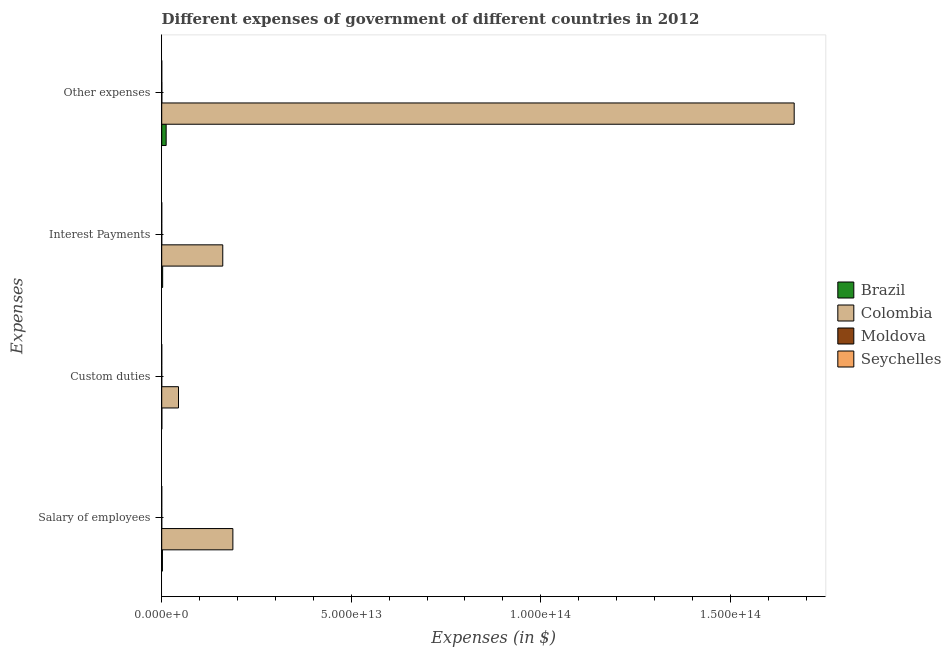How many different coloured bars are there?
Offer a very short reply. 4. Are the number of bars per tick equal to the number of legend labels?
Provide a succinct answer. Yes. How many bars are there on the 3rd tick from the top?
Offer a very short reply. 4. What is the label of the 3rd group of bars from the top?
Your answer should be compact. Custom duties. What is the amount spent on salary of employees in Colombia?
Offer a very short reply. 1.88e+13. Across all countries, what is the maximum amount spent on salary of employees?
Provide a succinct answer. 1.88e+13. Across all countries, what is the minimum amount spent on custom duties?
Offer a terse response. 1.13e+09. In which country was the amount spent on custom duties minimum?
Keep it short and to the point. Seychelles. What is the total amount spent on interest payments in the graph?
Keep it short and to the point. 1.64e+13. What is the difference between the amount spent on interest payments in Colombia and that in Brazil?
Provide a succinct answer. 1.59e+13. What is the difference between the amount spent on custom duties in Moldova and the amount spent on interest payments in Colombia?
Your answer should be very brief. -1.61e+13. What is the average amount spent on other expenses per country?
Your response must be concise. 4.20e+13. What is the difference between the amount spent on other expenses and amount spent on interest payments in Colombia?
Provide a succinct answer. 1.51e+14. What is the ratio of the amount spent on salary of employees in Moldova to that in Colombia?
Make the answer very short. 0. Is the amount spent on other expenses in Brazil less than that in Seychelles?
Your answer should be compact. No. Is the difference between the amount spent on interest payments in Seychelles and Brazil greater than the difference between the amount spent on custom duties in Seychelles and Brazil?
Your response must be concise. No. What is the difference between the highest and the second highest amount spent on interest payments?
Your answer should be compact. 1.59e+13. What is the difference between the highest and the lowest amount spent on custom duties?
Your response must be concise. 4.43e+12. Is the sum of the amount spent on salary of employees in Seychelles and Moldova greater than the maximum amount spent on other expenses across all countries?
Your response must be concise. No. Is it the case that in every country, the sum of the amount spent on interest payments and amount spent on other expenses is greater than the sum of amount spent on custom duties and amount spent on salary of employees?
Provide a succinct answer. No. What does the 2nd bar from the top in Other expenses represents?
Your response must be concise. Moldova. What does the 2nd bar from the bottom in Salary of employees represents?
Provide a short and direct response. Colombia. How many bars are there?
Provide a succinct answer. 16. How many countries are there in the graph?
Provide a succinct answer. 4. What is the difference between two consecutive major ticks on the X-axis?
Ensure brevity in your answer.  5.00e+13. Are the values on the major ticks of X-axis written in scientific E-notation?
Provide a short and direct response. Yes. Does the graph contain any zero values?
Provide a succinct answer. No. How are the legend labels stacked?
Your answer should be compact. Vertical. What is the title of the graph?
Make the answer very short. Different expenses of government of different countries in 2012. Does "Morocco" appear as one of the legend labels in the graph?
Ensure brevity in your answer.  No. What is the label or title of the X-axis?
Keep it short and to the point. Expenses (in $). What is the label or title of the Y-axis?
Provide a succinct answer. Expenses. What is the Expenses (in $) of Brazil in Salary of employees?
Your answer should be compact. 1.86e+11. What is the Expenses (in $) of Colombia in Salary of employees?
Ensure brevity in your answer.  1.88e+13. What is the Expenses (in $) of Moldova in Salary of employees?
Offer a very short reply. 3.94e+09. What is the Expenses (in $) of Seychelles in Salary of employees?
Offer a very short reply. 1.18e+09. What is the Expenses (in $) in Brazil in Custom duties?
Provide a succinct answer. 3.11e+1. What is the Expenses (in $) in Colombia in Custom duties?
Your answer should be compact. 4.43e+12. What is the Expenses (in $) of Moldova in Custom duties?
Provide a succinct answer. 1.25e+09. What is the Expenses (in $) of Seychelles in Custom duties?
Your answer should be compact. 1.13e+09. What is the Expenses (in $) in Brazil in Interest Payments?
Keep it short and to the point. 2.48e+11. What is the Expenses (in $) of Colombia in Interest Payments?
Provide a succinct answer. 1.61e+13. What is the Expenses (in $) in Moldova in Interest Payments?
Keep it short and to the point. 6.66e+08. What is the Expenses (in $) in Seychelles in Interest Payments?
Offer a very short reply. 5.62e+08. What is the Expenses (in $) in Brazil in Other expenses?
Your answer should be compact. 1.17e+12. What is the Expenses (in $) in Colombia in Other expenses?
Provide a short and direct response. 1.67e+14. What is the Expenses (in $) in Moldova in Other expenses?
Offer a terse response. 2.94e+1. What is the Expenses (in $) in Seychelles in Other expenses?
Offer a terse response. 4.04e+09. Across all Expenses, what is the maximum Expenses (in $) in Brazil?
Make the answer very short. 1.17e+12. Across all Expenses, what is the maximum Expenses (in $) in Colombia?
Offer a very short reply. 1.67e+14. Across all Expenses, what is the maximum Expenses (in $) of Moldova?
Offer a terse response. 2.94e+1. Across all Expenses, what is the maximum Expenses (in $) of Seychelles?
Offer a terse response. 4.04e+09. Across all Expenses, what is the minimum Expenses (in $) in Brazil?
Provide a succinct answer. 3.11e+1. Across all Expenses, what is the minimum Expenses (in $) in Colombia?
Your response must be concise. 4.43e+12. Across all Expenses, what is the minimum Expenses (in $) in Moldova?
Provide a succinct answer. 6.66e+08. Across all Expenses, what is the minimum Expenses (in $) of Seychelles?
Your answer should be very brief. 5.62e+08. What is the total Expenses (in $) in Brazil in the graph?
Keep it short and to the point. 1.64e+12. What is the total Expenses (in $) in Colombia in the graph?
Your answer should be very brief. 2.06e+14. What is the total Expenses (in $) in Moldova in the graph?
Offer a terse response. 3.52e+1. What is the total Expenses (in $) in Seychelles in the graph?
Keep it short and to the point. 6.91e+09. What is the difference between the Expenses (in $) of Brazil in Salary of employees and that in Custom duties?
Provide a succinct answer. 1.55e+11. What is the difference between the Expenses (in $) in Colombia in Salary of employees and that in Custom duties?
Provide a short and direct response. 1.43e+13. What is the difference between the Expenses (in $) of Moldova in Salary of employees and that in Custom duties?
Make the answer very short. 2.70e+09. What is the difference between the Expenses (in $) of Seychelles in Salary of employees and that in Custom duties?
Ensure brevity in your answer.  4.31e+07. What is the difference between the Expenses (in $) in Brazil in Salary of employees and that in Interest Payments?
Make the answer very short. -6.16e+1. What is the difference between the Expenses (in $) of Colombia in Salary of employees and that in Interest Payments?
Provide a short and direct response. 2.67e+12. What is the difference between the Expenses (in $) of Moldova in Salary of employees and that in Interest Payments?
Offer a very short reply. 3.28e+09. What is the difference between the Expenses (in $) in Seychelles in Salary of employees and that in Interest Payments?
Ensure brevity in your answer.  6.14e+08. What is the difference between the Expenses (in $) in Brazil in Salary of employees and that in Other expenses?
Provide a succinct answer. -9.85e+11. What is the difference between the Expenses (in $) of Colombia in Salary of employees and that in Other expenses?
Offer a very short reply. -1.48e+14. What is the difference between the Expenses (in $) in Moldova in Salary of employees and that in Other expenses?
Offer a very short reply. -2.54e+1. What is the difference between the Expenses (in $) of Seychelles in Salary of employees and that in Other expenses?
Ensure brevity in your answer.  -2.86e+09. What is the difference between the Expenses (in $) in Brazil in Custom duties and that in Interest Payments?
Give a very brief answer. -2.17e+11. What is the difference between the Expenses (in $) in Colombia in Custom duties and that in Interest Payments?
Provide a succinct answer. -1.17e+13. What is the difference between the Expenses (in $) of Moldova in Custom duties and that in Interest Payments?
Offer a terse response. 5.81e+08. What is the difference between the Expenses (in $) of Seychelles in Custom duties and that in Interest Payments?
Keep it short and to the point. 5.71e+08. What is the difference between the Expenses (in $) in Brazil in Custom duties and that in Other expenses?
Your response must be concise. -1.14e+12. What is the difference between the Expenses (in $) of Colombia in Custom duties and that in Other expenses?
Offer a terse response. -1.62e+14. What is the difference between the Expenses (in $) in Moldova in Custom duties and that in Other expenses?
Your response must be concise. -2.81e+1. What is the difference between the Expenses (in $) of Seychelles in Custom duties and that in Other expenses?
Make the answer very short. -2.90e+09. What is the difference between the Expenses (in $) of Brazil in Interest Payments and that in Other expenses?
Your answer should be very brief. -9.23e+11. What is the difference between the Expenses (in $) of Colombia in Interest Payments and that in Other expenses?
Offer a terse response. -1.51e+14. What is the difference between the Expenses (in $) in Moldova in Interest Payments and that in Other expenses?
Provide a short and direct response. -2.87e+1. What is the difference between the Expenses (in $) of Seychelles in Interest Payments and that in Other expenses?
Your response must be concise. -3.47e+09. What is the difference between the Expenses (in $) in Brazil in Salary of employees and the Expenses (in $) in Colombia in Custom duties?
Offer a terse response. -4.24e+12. What is the difference between the Expenses (in $) of Brazil in Salary of employees and the Expenses (in $) of Moldova in Custom duties?
Your answer should be compact. 1.85e+11. What is the difference between the Expenses (in $) of Brazil in Salary of employees and the Expenses (in $) of Seychelles in Custom duties?
Your answer should be very brief. 1.85e+11. What is the difference between the Expenses (in $) of Colombia in Salary of employees and the Expenses (in $) of Moldova in Custom duties?
Provide a short and direct response. 1.88e+13. What is the difference between the Expenses (in $) in Colombia in Salary of employees and the Expenses (in $) in Seychelles in Custom duties?
Offer a terse response. 1.88e+13. What is the difference between the Expenses (in $) of Moldova in Salary of employees and the Expenses (in $) of Seychelles in Custom duties?
Your answer should be very brief. 2.81e+09. What is the difference between the Expenses (in $) of Brazil in Salary of employees and the Expenses (in $) of Colombia in Interest Payments?
Make the answer very short. -1.59e+13. What is the difference between the Expenses (in $) of Brazil in Salary of employees and the Expenses (in $) of Moldova in Interest Payments?
Your answer should be compact. 1.85e+11. What is the difference between the Expenses (in $) of Brazil in Salary of employees and the Expenses (in $) of Seychelles in Interest Payments?
Offer a very short reply. 1.86e+11. What is the difference between the Expenses (in $) of Colombia in Salary of employees and the Expenses (in $) of Moldova in Interest Payments?
Ensure brevity in your answer.  1.88e+13. What is the difference between the Expenses (in $) in Colombia in Salary of employees and the Expenses (in $) in Seychelles in Interest Payments?
Keep it short and to the point. 1.88e+13. What is the difference between the Expenses (in $) of Moldova in Salary of employees and the Expenses (in $) of Seychelles in Interest Payments?
Make the answer very short. 3.38e+09. What is the difference between the Expenses (in $) in Brazil in Salary of employees and the Expenses (in $) in Colombia in Other expenses?
Your answer should be very brief. -1.67e+14. What is the difference between the Expenses (in $) in Brazil in Salary of employees and the Expenses (in $) in Moldova in Other expenses?
Your response must be concise. 1.57e+11. What is the difference between the Expenses (in $) of Brazil in Salary of employees and the Expenses (in $) of Seychelles in Other expenses?
Your answer should be very brief. 1.82e+11. What is the difference between the Expenses (in $) of Colombia in Salary of employees and the Expenses (in $) of Moldova in Other expenses?
Ensure brevity in your answer.  1.87e+13. What is the difference between the Expenses (in $) of Colombia in Salary of employees and the Expenses (in $) of Seychelles in Other expenses?
Your response must be concise. 1.88e+13. What is the difference between the Expenses (in $) of Moldova in Salary of employees and the Expenses (in $) of Seychelles in Other expenses?
Give a very brief answer. -9.21e+07. What is the difference between the Expenses (in $) of Brazil in Custom duties and the Expenses (in $) of Colombia in Interest Payments?
Make the answer very short. -1.61e+13. What is the difference between the Expenses (in $) in Brazil in Custom duties and the Expenses (in $) in Moldova in Interest Payments?
Give a very brief answer. 3.04e+1. What is the difference between the Expenses (in $) of Brazil in Custom duties and the Expenses (in $) of Seychelles in Interest Payments?
Provide a succinct answer. 3.05e+1. What is the difference between the Expenses (in $) of Colombia in Custom duties and the Expenses (in $) of Moldova in Interest Payments?
Give a very brief answer. 4.43e+12. What is the difference between the Expenses (in $) in Colombia in Custom duties and the Expenses (in $) in Seychelles in Interest Payments?
Your answer should be compact. 4.43e+12. What is the difference between the Expenses (in $) of Moldova in Custom duties and the Expenses (in $) of Seychelles in Interest Payments?
Provide a short and direct response. 6.86e+08. What is the difference between the Expenses (in $) in Brazil in Custom duties and the Expenses (in $) in Colombia in Other expenses?
Provide a succinct answer. -1.67e+14. What is the difference between the Expenses (in $) in Brazil in Custom duties and the Expenses (in $) in Moldova in Other expenses?
Your answer should be very brief. 1.69e+09. What is the difference between the Expenses (in $) in Brazil in Custom duties and the Expenses (in $) in Seychelles in Other expenses?
Your response must be concise. 2.70e+1. What is the difference between the Expenses (in $) in Colombia in Custom duties and the Expenses (in $) in Moldova in Other expenses?
Make the answer very short. 4.40e+12. What is the difference between the Expenses (in $) of Colombia in Custom duties and the Expenses (in $) of Seychelles in Other expenses?
Make the answer very short. 4.42e+12. What is the difference between the Expenses (in $) of Moldova in Custom duties and the Expenses (in $) of Seychelles in Other expenses?
Provide a succinct answer. -2.79e+09. What is the difference between the Expenses (in $) of Brazil in Interest Payments and the Expenses (in $) of Colombia in Other expenses?
Provide a short and direct response. -1.67e+14. What is the difference between the Expenses (in $) in Brazil in Interest Payments and the Expenses (in $) in Moldova in Other expenses?
Offer a terse response. 2.18e+11. What is the difference between the Expenses (in $) in Brazil in Interest Payments and the Expenses (in $) in Seychelles in Other expenses?
Ensure brevity in your answer.  2.44e+11. What is the difference between the Expenses (in $) in Colombia in Interest Payments and the Expenses (in $) in Moldova in Other expenses?
Give a very brief answer. 1.61e+13. What is the difference between the Expenses (in $) of Colombia in Interest Payments and the Expenses (in $) of Seychelles in Other expenses?
Give a very brief answer. 1.61e+13. What is the difference between the Expenses (in $) of Moldova in Interest Payments and the Expenses (in $) of Seychelles in Other expenses?
Offer a terse response. -3.37e+09. What is the average Expenses (in $) of Brazil per Expenses?
Give a very brief answer. 4.09e+11. What is the average Expenses (in $) in Colombia per Expenses?
Offer a very short reply. 5.15e+13. What is the average Expenses (in $) of Moldova per Expenses?
Provide a succinct answer. 8.81e+09. What is the average Expenses (in $) in Seychelles per Expenses?
Your answer should be very brief. 1.73e+09. What is the difference between the Expenses (in $) in Brazil and Expenses (in $) in Colombia in Salary of employees?
Offer a very short reply. -1.86e+13. What is the difference between the Expenses (in $) in Brazil and Expenses (in $) in Moldova in Salary of employees?
Give a very brief answer. 1.82e+11. What is the difference between the Expenses (in $) in Brazil and Expenses (in $) in Seychelles in Salary of employees?
Provide a succinct answer. 1.85e+11. What is the difference between the Expenses (in $) of Colombia and Expenses (in $) of Moldova in Salary of employees?
Provide a short and direct response. 1.88e+13. What is the difference between the Expenses (in $) in Colombia and Expenses (in $) in Seychelles in Salary of employees?
Provide a succinct answer. 1.88e+13. What is the difference between the Expenses (in $) in Moldova and Expenses (in $) in Seychelles in Salary of employees?
Your response must be concise. 2.77e+09. What is the difference between the Expenses (in $) of Brazil and Expenses (in $) of Colombia in Custom duties?
Provide a short and direct response. -4.40e+12. What is the difference between the Expenses (in $) in Brazil and Expenses (in $) in Moldova in Custom duties?
Provide a short and direct response. 2.98e+1. What is the difference between the Expenses (in $) of Brazil and Expenses (in $) of Seychelles in Custom duties?
Ensure brevity in your answer.  2.99e+1. What is the difference between the Expenses (in $) of Colombia and Expenses (in $) of Moldova in Custom duties?
Your answer should be compact. 4.43e+12. What is the difference between the Expenses (in $) in Colombia and Expenses (in $) in Seychelles in Custom duties?
Ensure brevity in your answer.  4.43e+12. What is the difference between the Expenses (in $) of Moldova and Expenses (in $) of Seychelles in Custom duties?
Provide a succinct answer. 1.15e+08. What is the difference between the Expenses (in $) of Brazil and Expenses (in $) of Colombia in Interest Payments?
Your answer should be compact. -1.59e+13. What is the difference between the Expenses (in $) in Brazil and Expenses (in $) in Moldova in Interest Payments?
Make the answer very short. 2.47e+11. What is the difference between the Expenses (in $) of Brazil and Expenses (in $) of Seychelles in Interest Payments?
Provide a short and direct response. 2.47e+11. What is the difference between the Expenses (in $) in Colombia and Expenses (in $) in Moldova in Interest Payments?
Offer a terse response. 1.61e+13. What is the difference between the Expenses (in $) in Colombia and Expenses (in $) in Seychelles in Interest Payments?
Offer a very short reply. 1.61e+13. What is the difference between the Expenses (in $) of Moldova and Expenses (in $) of Seychelles in Interest Payments?
Your answer should be very brief. 1.05e+08. What is the difference between the Expenses (in $) in Brazil and Expenses (in $) in Colombia in Other expenses?
Your answer should be very brief. -1.66e+14. What is the difference between the Expenses (in $) of Brazil and Expenses (in $) of Moldova in Other expenses?
Your answer should be very brief. 1.14e+12. What is the difference between the Expenses (in $) in Brazil and Expenses (in $) in Seychelles in Other expenses?
Give a very brief answer. 1.17e+12. What is the difference between the Expenses (in $) of Colombia and Expenses (in $) of Moldova in Other expenses?
Your answer should be very brief. 1.67e+14. What is the difference between the Expenses (in $) in Colombia and Expenses (in $) in Seychelles in Other expenses?
Keep it short and to the point. 1.67e+14. What is the difference between the Expenses (in $) in Moldova and Expenses (in $) in Seychelles in Other expenses?
Make the answer very short. 2.53e+1. What is the ratio of the Expenses (in $) in Brazil in Salary of employees to that in Custom duties?
Provide a short and direct response. 5.99. What is the ratio of the Expenses (in $) in Colombia in Salary of employees to that in Custom duties?
Provide a succinct answer. 4.24. What is the ratio of the Expenses (in $) of Moldova in Salary of employees to that in Custom duties?
Give a very brief answer. 3.16. What is the ratio of the Expenses (in $) of Seychelles in Salary of employees to that in Custom duties?
Keep it short and to the point. 1.04. What is the ratio of the Expenses (in $) of Brazil in Salary of employees to that in Interest Payments?
Make the answer very short. 0.75. What is the ratio of the Expenses (in $) in Colombia in Salary of employees to that in Interest Payments?
Ensure brevity in your answer.  1.17. What is the ratio of the Expenses (in $) of Moldova in Salary of employees to that in Interest Payments?
Your answer should be compact. 5.92. What is the ratio of the Expenses (in $) in Seychelles in Salary of employees to that in Interest Payments?
Offer a terse response. 2.09. What is the ratio of the Expenses (in $) in Brazil in Salary of employees to that in Other expenses?
Ensure brevity in your answer.  0.16. What is the ratio of the Expenses (in $) of Colombia in Salary of employees to that in Other expenses?
Provide a short and direct response. 0.11. What is the ratio of the Expenses (in $) in Moldova in Salary of employees to that in Other expenses?
Offer a terse response. 0.13. What is the ratio of the Expenses (in $) of Seychelles in Salary of employees to that in Other expenses?
Your answer should be very brief. 0.29. What is the ratio of the Expenses (in $) in Brazil in Custom duties to that in Interest Payments?
Keep it short and to the point. 0.13. What is the ratio of the Expenses (in $) of Colombia in Custom duties to that in Interest Payments?
Your response must be concise. 0.28. What is the ratio of the Expenses (in $) in Moldova in Custom duties to that in Interest Payments?
Keep it short and to the point. 1.87. What is the ratio of the Expenses (in $) in Seychelles in Custom duties to that in Interest Payments?
Offer a very short reply. 2.02. What is the ratio of the Expenses (in $) of Brazil in Custom duties to that in Other expenses?
Provide a succinct answer. 0.03. What is the ratio of the Expenses (in $) in Colombia in Custom duties to that in Other expenses?
Ensure brevity in your answer.  0.03. What is the ratio of the Expenses (in $) of Moldova in Custom duties to that in Other expenses?
Provide a succinct answer. 0.04. What is the ratio of the Expenses (in $) in Seychelles in Custom duties to that in Other expenses?
Offer a very short reply. 0.28. What is the ratio of the Expenses (in $) of Brazil in Interest Payments to that in Other expenses?
Your response must be concise. 0.21. What is the ratio of the Expenses (in $) in Colombia in Interest Payments to that in Other expenses?
Keep it short and to the point. 0.1. What is the ratio of the Expenses (in $) in Moldova in Interest Payments to that in Other expenses?
Keep it short and to the point. 0.02. What is the ratio of the Expenses (in $) in Seychelles in Interest Payments to that in Other expenses?
Your answer should be compact. 0.14. What is the difference between the highest and the second highest Expenses (in $) of Brazil?
Offer a very short reply. 9.23e+11. What is the difference between the highest and the second highest Expenses (in $) of Colombia?
Offer a terse response. 1.48e+14. What is the difference between the highest and the second highest Expenses (in $) in Moldova?
Your answer should be compact. 2.54e+1. What is the difference between the highest and the second highest Expenses (in $) of Seychelles?
Offer a very short reply. 2.86e+09. What is the difference between the highest and the lowest Expenses (in $) in Brazil?
Your answer should be compact. 1.14e+12. What is the difference between the highest and the lowest Expenses (in $) of Colombia?
Your answer should be compact. 1.62e+14. What is the difference between the highest and the lowest Expenses (in $) of Moldova?
Offer a terse response. 2.87e+1. What is the difference between the highest and the lowest Expenses (in $) in Seychelles?
Provide a succinct answer. 3.47e+09. 